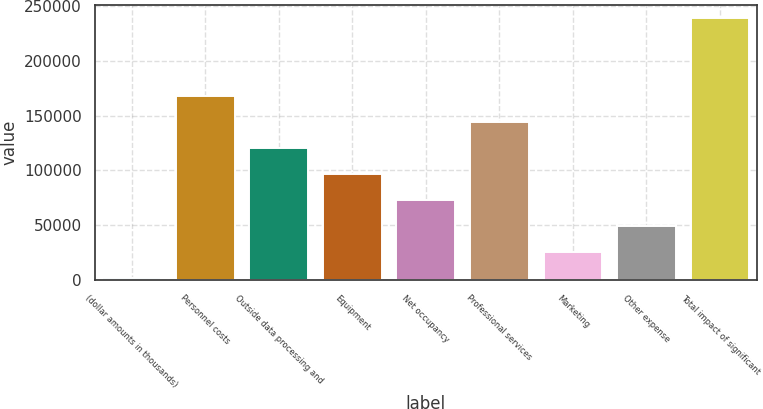Convert chart to OTSL. <chart><loc_0><loc_0><loc_500><loc_500><bar_chart><fcel>(dollar amounts in thousands)<fcel>Personnel costs<fcel>Outside data processing and<fcel>Equipment<fcel>Net occupancy<fcel>Professional services<fcel>Marketing<fcel>Other expense<fcel>Total impact of significant<nl><fcel>2016<fcel>168148<fcel>120682<fcel>96948.8<fcel>73215.6<fcel>144415<fcel>25749.2<fcel>49482.4<fcel>239348<nl></chart> 